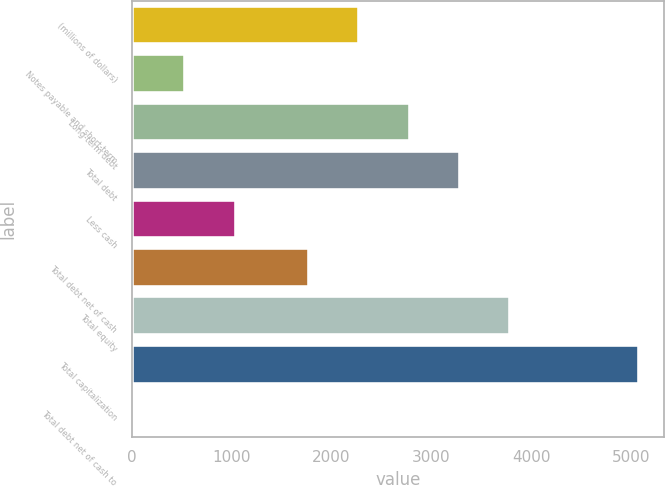Convert chart. <chart><loc_0><loc_0><loc_500><loc_500><bar_chart><fcel>(millions of dollars)<fcel>Notes payable and short-term<fcel>Long-term debt<fcel>Total debt<fcel>Less cash<fcel>Total debt net of cash<fcel>Total equity<fcel>Total capitalization<fcel>Total debt net of cash to<nl><fcel>2280.07<fcel>539.27<fcel>2784.34<fcel>3288.61<fcel>1043.54<fcel>1775.8<fcel>3792.88<fcel>5077.7<fcel>35<nl></chart> 